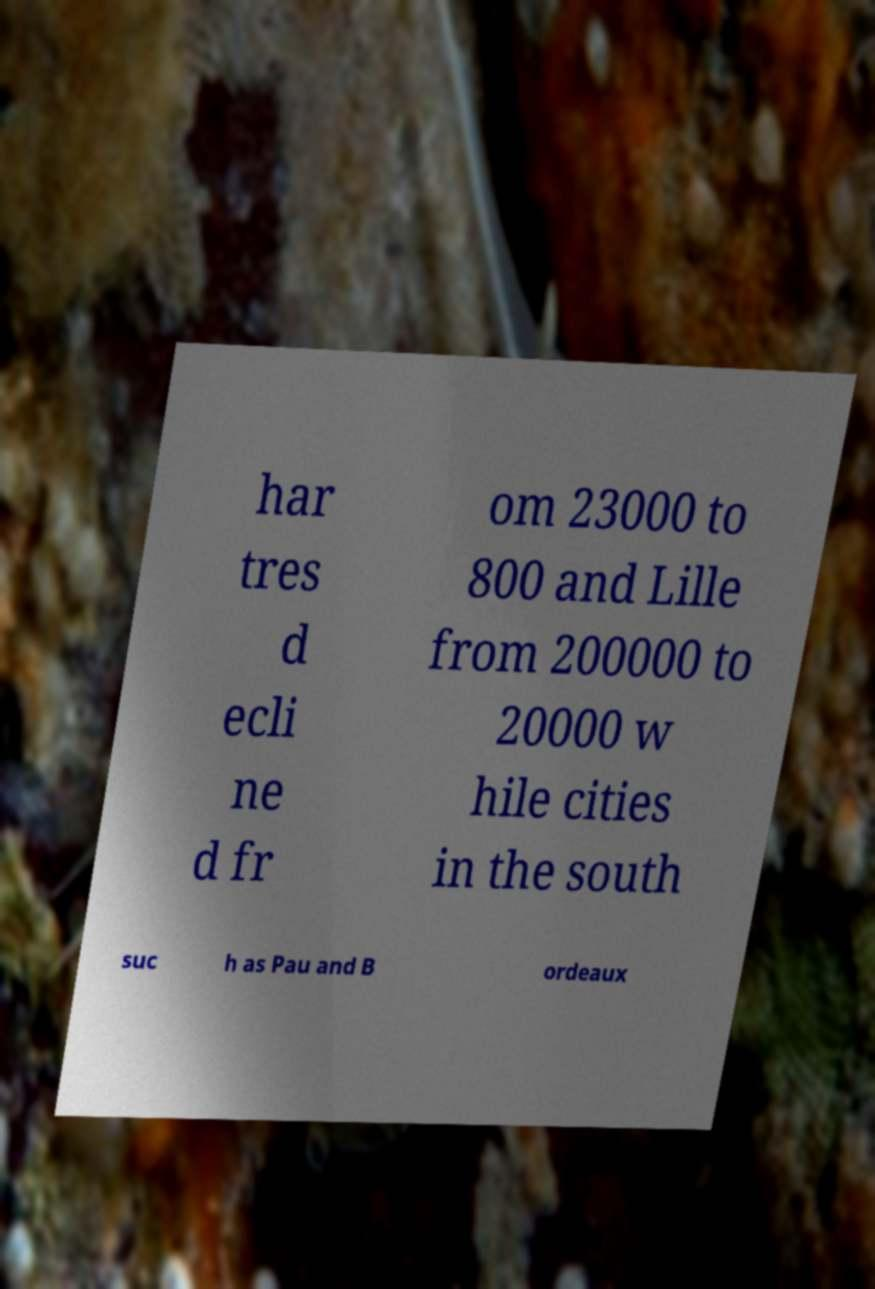I need the written content from this picture converted into text. Can you do that? har tres d ecli ne d fr om 23000 to 800 and Lille from 200000 to 20000 w hile cities in the south suc h as Pau and B ordeaux 